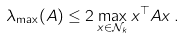<formula> <loc_0><loc_0><loc_500><loc_500>\lambda _ { \max } ( A ) \leq 2 \max _ { x \in \mathcal { N } _ { k } } x ^ { \top } A x \, .</formula> 